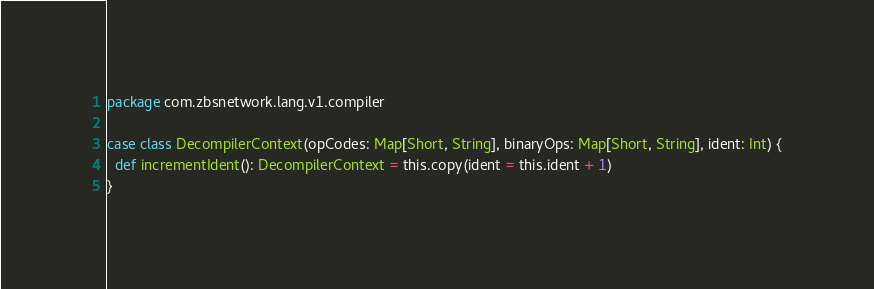<code> <loc_0><loc_0><loc_500><loc_500><_Scala_>package com.zbsnetwork.lang.v1.compiler

case class DecompilerContext(opCodes: Map[Short, String], binaryOps: Map[Short, String], ident: Int) {
  def incrementIdent(): DecompilerContext = this.copy(ident = this.ident + 1)
}
</code> 